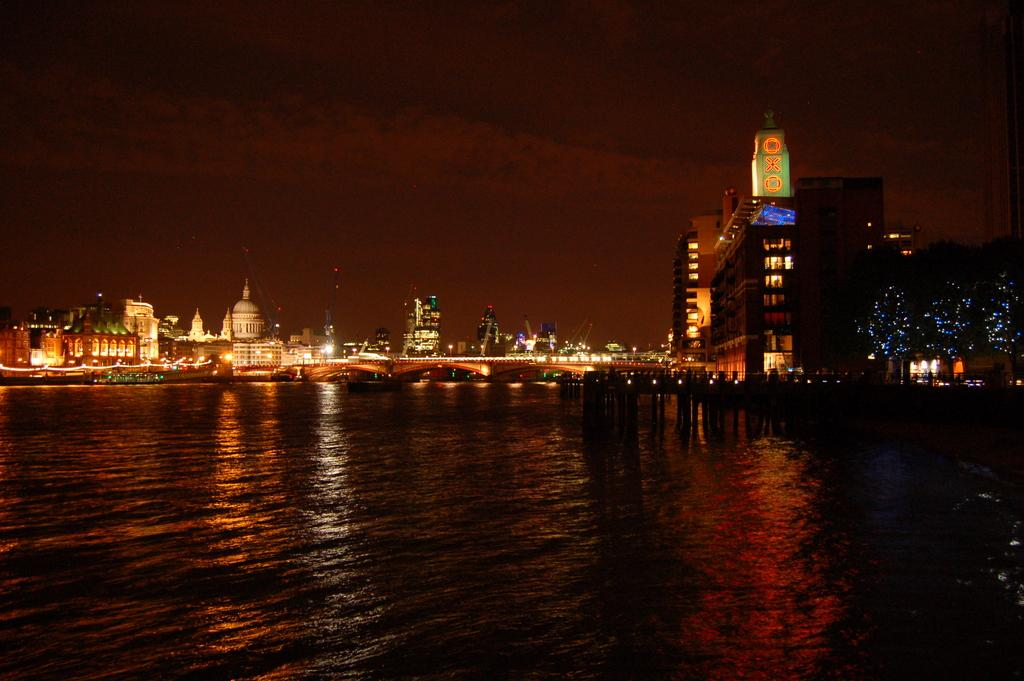What is the primary element visible in the image? There is water in the image. What type of structures can be seen in the image? There are buildings and towers in the image. What type of lighting is present in the image? Electric lights are visible in the image. What type of vegetation is present in the image? Trees are present in the image. What part of the natural environment is visible in the image? The sky is visible in the image. What type of cough medicine is visible in the image? There is no cough medicine present in the image. What decision is being made by the buildings in the image? Buildings do not make decisions; they are inanimate structures. 